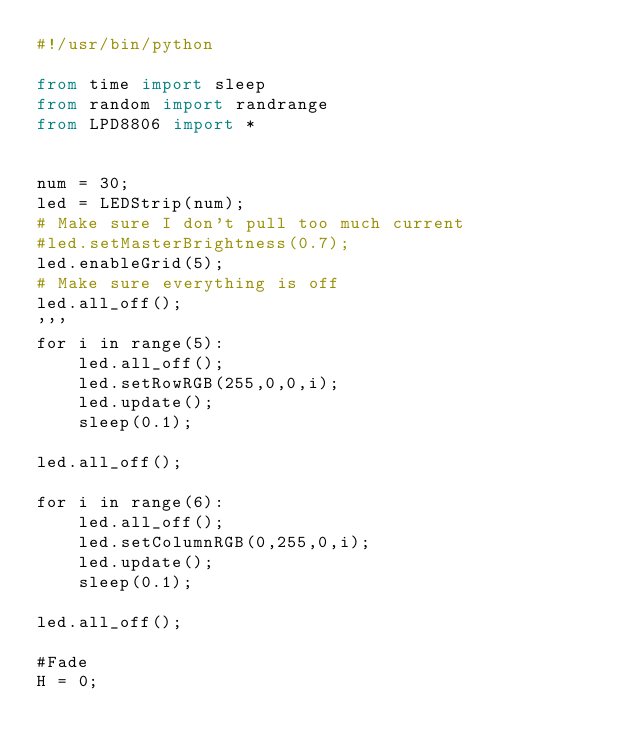<code> <loc_0><loc_0><loc_500><loc_500><_Python_>#!/usr/bin/python

from time import sleep
from random import randrange
from LPD8806 import *


num = 30;
led = LEDStrip(num);
# Make sure I don't pull too much current
#led.setMasterBrightness(0.7);
led.enableGrid(5);
# Make sure everything is off
led.all_off();
'''
for i in range(5):
	led.all_off();
	led.setRowRGB(255,0,0,i);
	led.update();
	sleep(0.1);

led.all_off();

for i in range(6):
	led.all_off();
	led.setColumnRGB(0,255,0,i);
	led.update();
	sleep(0.1);

led.all_off();

#Fade
H = 0;</code> 